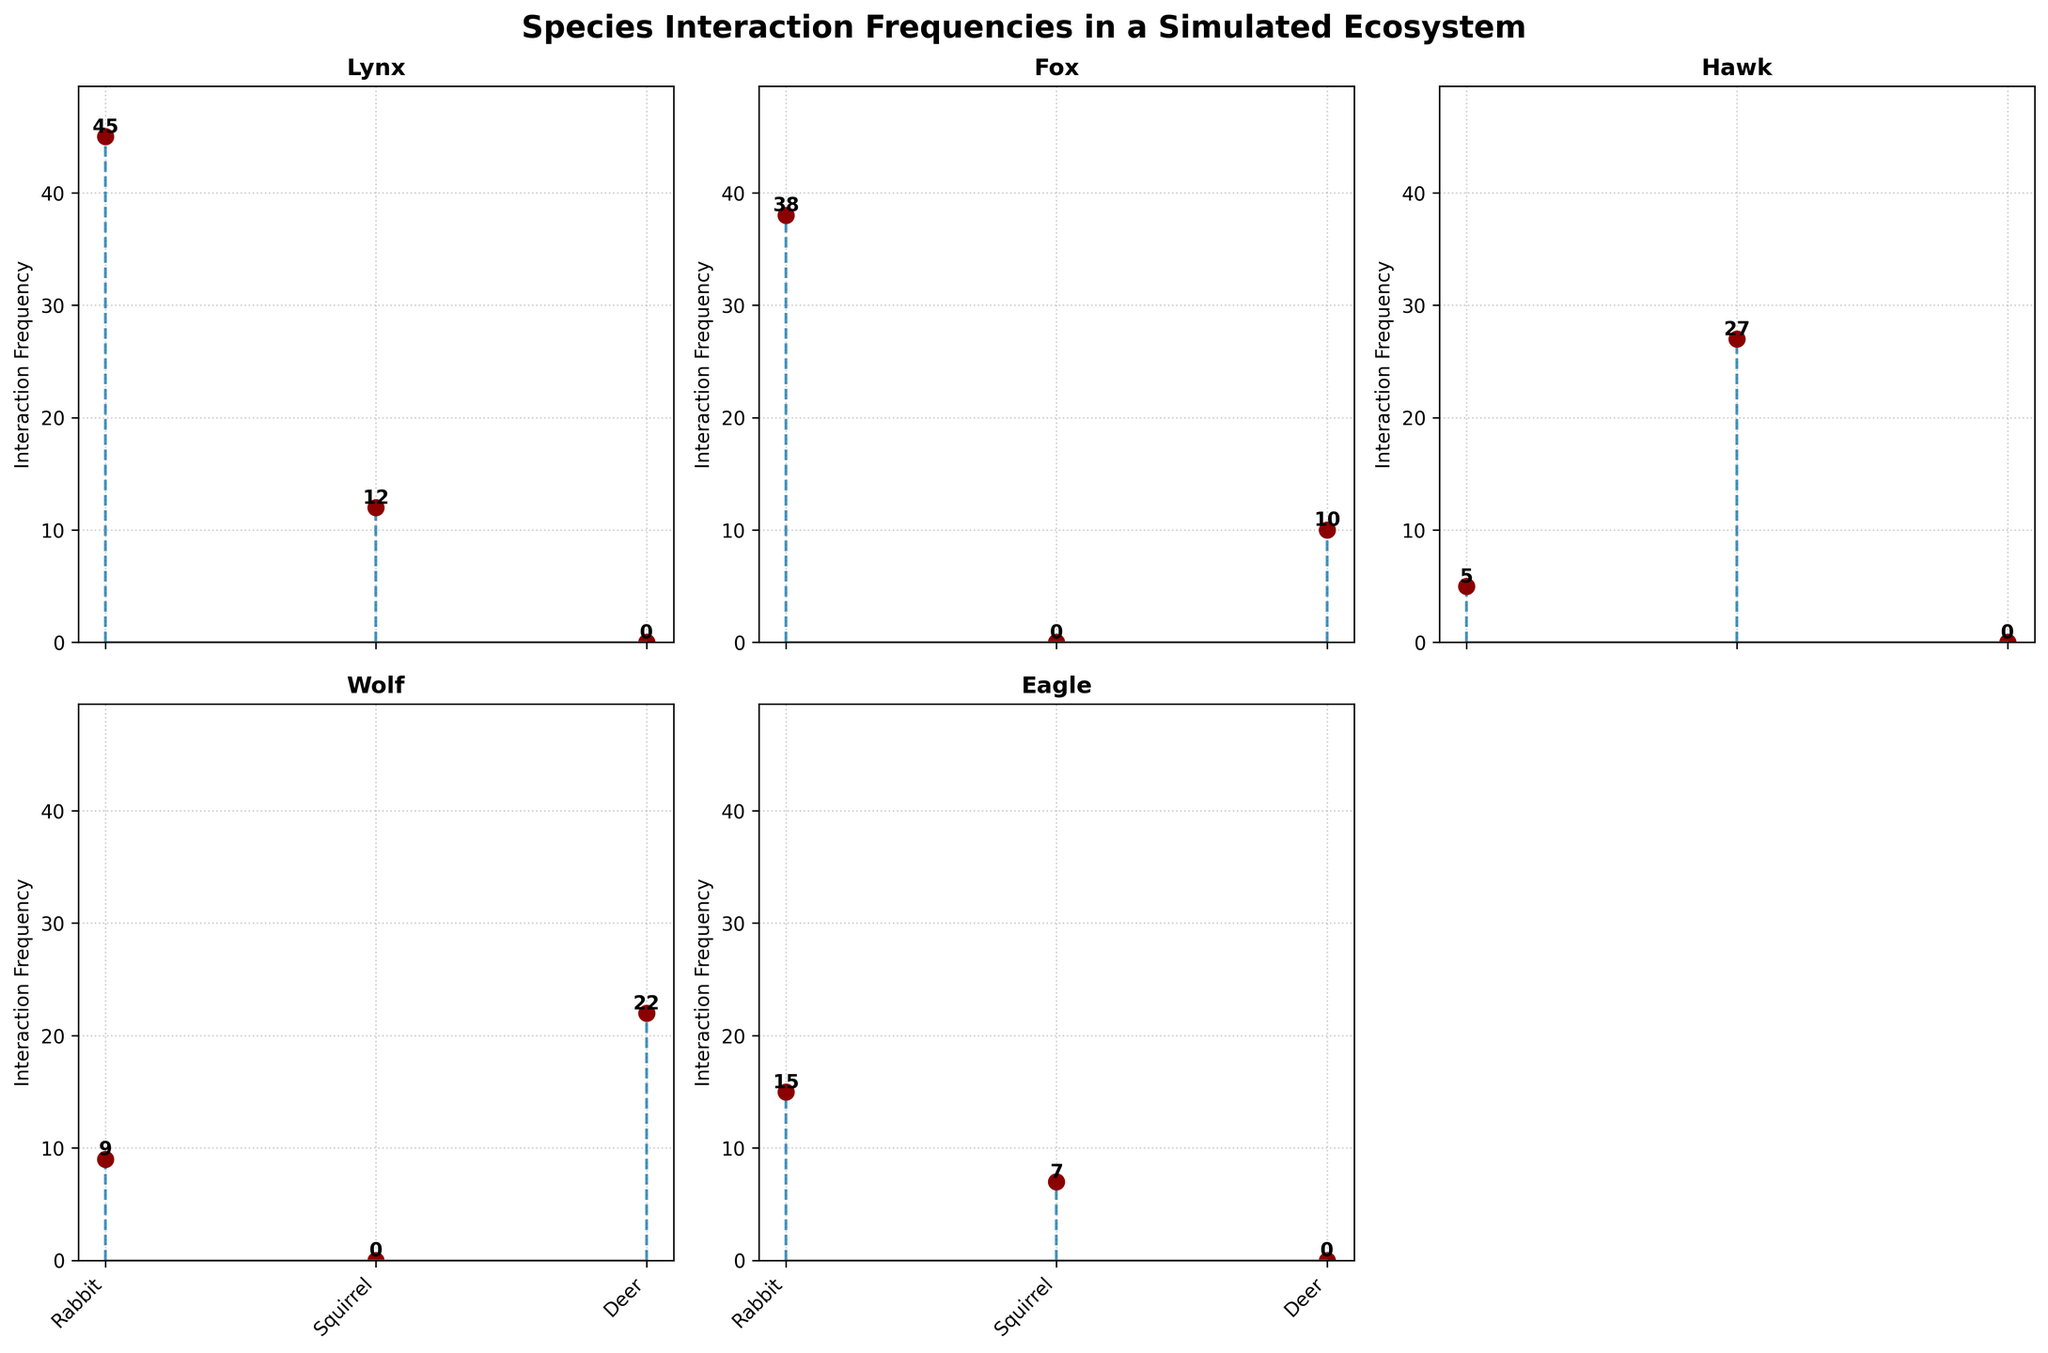What is the highest interaction frequency for Lynx? To find the highest interaction frequency for Lynx, look at the subplot for Lynx. The highest value on this subplot is indicated by the stem reaching the highest y-value, which corresponds to Rabbit with a frequency of 45.
Answer: 45 Which predator interacts with Deer the most? Focus on the subplots for predators that include Deer as an interaction type (Wolf and Fox). Compare their frequencies for Deer: Wolf has 22, and Fox has 10. Thus, Wolf interacts with Deer the most.
Answer: Wolf What’s the total interaction frequency for the predator Fox across all prey? Inspect the Fox subplot and sum all frequencies: Rabbit (38) + Deer (10) = 48. So, the total is 48.
Answer: 48 Which species has the lowest interaction frequency with Rabbit? Check all subplots that have Rabbit as an interaction type. The frequencies are: Lynx (45), Fox (38), Hawk (5), Wolf (9), and Eagle (15). The lowest frequency is for the Hawk with 5.
Answer: Hawk What is the average interaction frequency for Hawk? On the Hawk’s subplot, sum the interaction frequencies: Squirrel (27) + Rabbit (5). There are 2 interactions, so the average is (27+5)/2 = 16.
Answer: 16 Compare the overall interaction frequencies between Eagle and Hawk. Which one is higher? Summing up the interaction frequencies for Eagle (Rabbit: 15, Squirrel: 7) gives 22. For Hawk (Squirrel: 27, Rabbit: 5) gives 32. Hawk has the higher overall frequency.
Answer: Hawk What is the interaction frequency difference between Lynx and Fox with Rabbits? Lynx interacts with Rabbit with a frequency of 45. Fox interacts with Rabbit with a frequency of 38. The difference is 45 - 38 = 7.
Answer: 7 What prey type does Lynx interact the least with? On the Lynx subplot, compare the frequencies: Rabbit (45), Squirrel (12). The lowest frequency is for Squirrel.
Answer: Squirrel 